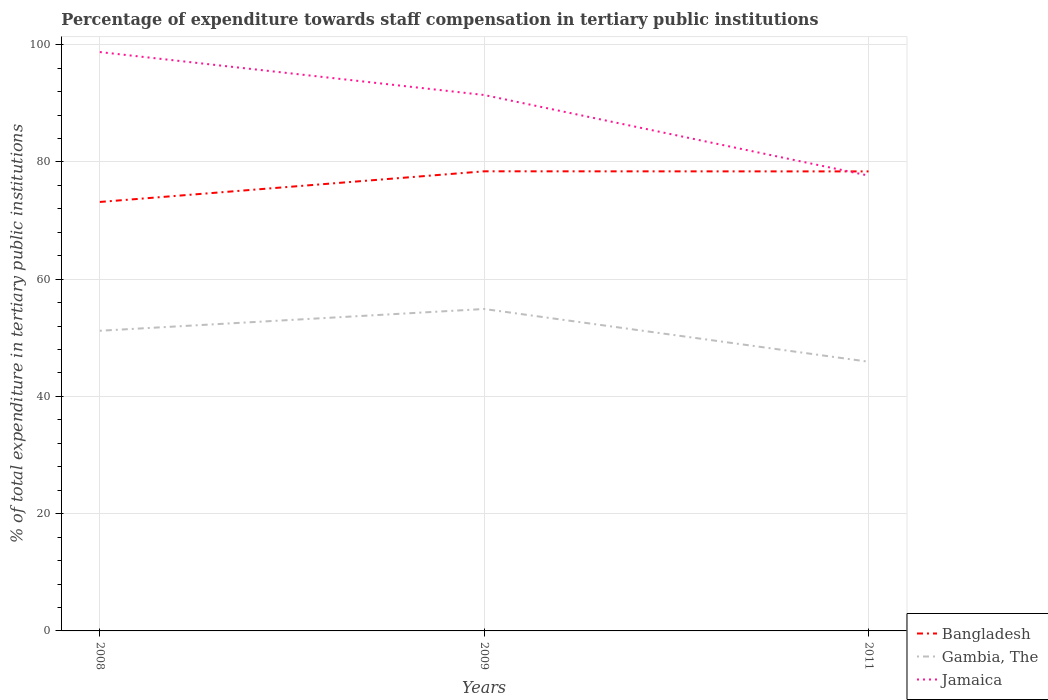Across all years, what is the maximum percentage of expenditure towards staff compensation in Jamaica?
Provide a succinct answer. 77.66. What is the total percentage of expenditure towards staff compensation in Bangladesh in the graph?
Your response must be concise. -5.23. What is the difference between the highest and the second highest percentage of expenditure towards staff compensation in Bangladesh?
Make the answer very short. 5.23. What is the difference between the highest and the lowest percentage of expenditure towards staff compensation in Jamaica?
Your answer should be compact. 2. Is the percentage of expenditure towards staff compensation in Jamaica strictly greater than the percentage of expenditure towards staff compensation in Bangladesh over the years?
Your answer should be very brief. No. How many years are there in the graph?
Make the answer very short. 3. Are the values on the major ticks of Y-axis written in scientific E-notation?
Make the answer very short. No. Does the graph contain any zero values?
Provide a succinct answer. No. What is the title of the graph?
Your response must be concise. Percentage of expenditure towards staff compensation in tertiary public institutions. Does "Turkey" appear as one of the legend labels in the graph?
Your response must be concise. No. What is the label or title of the X-axis?
Your response must be concise. Years. What is the label or title of the Y-axis?
Your answer should be compact. % of total expenditure in tertiary public institutions. What is the % of total expenditure in tertiary public institutions in Bangladesh in 2008?
Provide a short and direct response. 73.17. What is the % of total expenditure in tertiary public institutions in Gambia, The in 2008?
Keep it short and to the point. 51.2. What is the % of total expenditure in tertiary public institutions in Jamaica in 2008?
Provide a short and direct response. 98.74. What is the % of total expenditure in tertiary public institutions of Bangladesh in 2009?
Provide a succinct answer. 78.4. What is the % of total expenditure in tertiary public institutions in Gambia, The in 2009?
Provide a succinct answer. 54.91. What is the % of total expenditure in tertiary public institutions in Jamaica in 2009?
Your response must be concise. 91.41. What is the % of total expenditure in tertiary public institutions of Bangladesh in 2011?
Make the answer very short. 78.38. What is the % of total expenditure in tertiary public institutions in Gambia, The in 2011?
Your answer should be compact. 45.92. What is the % of total expenditure in tertiary public institutions in Jamaica in 2011?
Provide a succinct answer. 77.66. Across all years, what is the maximum % of total expenditure in tertiary public institutions of Bangladesh?
Your answer should be compact. 78.4. Across all years, what is the maximum % of total expenditure in tertiary public institutions of Gambia, The?
Your answer should be very brief. 54.91. Across all years, what is the maximum % of total expenditure in tertiary public institutions of Jamaica?
Your response must be concise. 98.74. Across all years, what is the minimum % of total expenditure in tertiary public institutions in Bangladesh?
Offer a terse response. 73.17. Across all years, what is the minimum % of total expenditure in tertiary public institutions in Gambia, The?
Provide a short and direct response. 45.92. Across all years, what is the minimum % of total expenditure in tertiary public institutions in Jamaica?
Your response must be concise. 77.66. What is the total % of total expenditure in tertiary public institutions of Bangladesh in the graph?
Your response must be concise. 229.95. What is the total % of total expenditure in tertiary public institutions of Gambia, The in the graph?
Keep it short and to the point. 152.03. What is the total % of total expenditure in tertiary public institutions in Jamaica in the graph?
Make the answer very short. 267.81. What is the difference between the % of total expenditure in tertiary public institutions of Bangladesh in 2008 and that in 2009?
Offer a very short reply. -5.23. What is the difference between the % of total expenditure in tertiary public institutions in Gambia, The in 2008 and that in 2009?
Offer a terse response. -3.71. What is the difference between the % of total expenditure in tertiary public institutions of Jamaica in 2008 and that in 2009?
Your answer should be very brief. 7.32. What is the difference between the % of total expenditure in tertiary public institutions in Bangladesh in 2008 and that in 2011?
Provide a short and direct response. -5.21. What is the difference between the % of total expenditure in tertiary public institutions in Gambia, The in 2008 and that in 2011?
Ensure brevity in your answer.  5.28. What is the difference between the % of total expenditure in tertiary public institutions in Jamaica in 2008 and that in 2011?
Provide a succinct answer. 21.07. What is the difference between the % of total expenditure in tertiary public institutions of Bangladesh in 2009 and that in 2011?
Offer a very short reply. 0.02. What is the difference between the % of total expenditure in tertiary public institutions of Gambia, The in 2009 and that in 2011?
Keep it short and to the point. 8.99. What is the difference between the % of total expenditure in tertiary public institutions in Jamaica in 2009 and that in 2011?
Ensure brevity in your answer.  13.75. What is the difference between the % of total expenditure in tertiary public institutions in Bangladesh in 2008 and the % of total expenditure in tertiary public institutions in Gambia, The in 2009?
Give a very brief answer. 18.26. What is the difference between the % of total expenditure in tertiary public institutions in Bangladesh in 2008 and the % of total expenditure in tertiary public institutions in Jamaica in 2009?
Ensure brevity in your answer.  -18.24. What is the difference between the % of total expenditure in tertiary public institutions in Gambia, The in 2008 and the % of total expenditure in tertiary public institutions in Jamaica in 2009?
Your answer should be very brief. -40.21. What is the difference between the % of total expenditure in tertiary public institutions in Bangladesh in 2008 and the % of total expenditure in tertiary public institutions in Gambia, The in 2011?
Provide a succinct answer. 27.25. What is the difference between the % of total expenditure in tertiary public institutions of Bangladesh in 2008 and the % of total expenditure in tertiary public institutions of Jamaica in 2011?
Keep it short and to the point. -4.49. What is the difference between the % of total expenditure in tertiary public institutions in Gambia, The in 2008 and the % of total expenditure in tertiary public institutions in Jamaica in 2011?
Make the answer very short. -26.46. What is the difference between the % of total expenditure in tertiary public institutions of Bangladesh in 2009 and the % of total expenditure in tertiary public institutions of Gambia, The in 2011?
Offer a very short reply. 32.48. What is the difference between the % of total expenditure in tertiary public institutions in Bangladesh in 2009 and the % of total expenditure in tertiary public institutions in Jamaica in 2011?
Provide a short and direct response. 0.73. What is the difference between the % of total expenditure in tertiary public institutions in Gambia, The in 2009 and the % of total expenditure in tertiary public institutions in Jamaica in 2011?
Keep it short and to the point. -22.75. What is the average % of total expenditure in tertiary public institutions in Bangladesh per year?
Make the answer very short. 76.65. What is the average % of total expenditure in tertiary public institutions in Gambia, The per year?
Make the answer very short. 50.68. What is the average % of total expenditure in tertiary public institutions in Jamaica per year?
Make the answer very short. 89.27. In the year 2008, what is the difference between the % of total expenditure in tertiary public institutions of Bangladesh and % of total expenditure in tertiary public institutions of Gambia, The?
Offer a very short reply. 21.97. In the year 2008, what is the difference between the % of total expenditure in tertiary public institutions of Bangladesh and % of total expenditure in tertiary public institutions of Jamaica?
Your answer should be compact. -25.57. In the year 2008, what is the difference between the % of total expenditure in tertiary public institutions in Gambia, The and % of total expenditure in tertiary public institutions in Jamaica?
Offer a very short reply. -47.54. In the year 2009, what is the difference between the % of total expenditure in tertiary public institutions in Bangladesh and % of total expenditure in tertiary public institutions in Gambia, The?
Offer a terse response. 23.49. In the year 2009, what is the difference between the % of total expenditure in tertiary public institutions of Bangladesh and % of total expenditure in tertiary public institutions of Jamaica?
Your answer should be compact. -13.02. In the year 2009, what is the difference between the % of total expenditure in tertiary public institutions of Gambia, The and % of total expenditure in tertiary public institutions of Jamaica?
Ensure brevity in your answer.  -36.5. In the year 2011, what is the difference between the % of total expenditure in tertiary public institutions in Bangladesh and % of total expenditure in tertiary public institutions in Gambia, The?
Make the answer very short. 32.46. In the year 2011, what is the difference between the % of total expenditure in tertiary public institutions in Bangladesh and % of total expenditure in tertiary public institutions in Jamaica?
Offer a terse response. 0.72. In the year 2011, what is the difference between the % of total expenditure in tertiary public institutions in Gambia, The and % of total expenditure in tertiary public institutions in Jamaica?
Offer a terse response. -31.75. What is the ratio of the % of total expenditure in tertiary public institutions of Bangladesh in 2008 to that in 2009?
Give a very brief answer. 0.93. What is the ratio of the % of total expenditure in tertiary public institutions in Gambia, The in 2008 to that in 2009?
Your response must be concise. 0.93. What is the ratio of the % of total expenditure in tertiary public institutions of Jamaica in 2008 to that in 2009?
Your answer should be very brief. 1.08. What is the ratio of the % of total expenditure in tertiary public institutions of Bangladesh in 2008 to that in 2011?
Ensure brevity in your answer.  0.93. What is the ratio of the % of total expenditure in tertiary public institutions in Gambia, The in 2008 to that in 2011?
Make the answer very short. 1.11. What is the ratio of the % of total expenditure in tertiary public institutions in Jamaica in 2008 to that in 2011?
Ensure brevity in your answer.  1.27. What is the ratio of the % of total expenditure in tertiary public institutions of Bangladesh in 2009 to that in 2011?
Provide a short and direct response. 1. What is the ratio of the % of total expenditure in tertiary public institutions in Gambia, The in 2009 to that in 2011?
Offer a very short reply. 1.2. What is the ratio of the % of total expenditure in tertiary public institutions of Jamaica in 2009 to that in 2011?
Ensure brevity in your answer.  1.18. What is the difference between the highest and the second highest % of total expenditure in tertiary public institutions in Bangladesh?
Keep it short and to the point. 0.02. What is the difference between the highest and the second highest % of total expenditure in tertiary public institutions of Gambia, The?
Your answer should be compact. 3.71. What is the difference between the highest and the second highest % of total expenditure in tertiary public institutions of Jamaica?
Your response must be concise. 7.32. What is the difference between the highest and the lowest % of total expenditure in tertiary public institutions in Bangladesh?
Provide a short and direct response. 5.23. What is the difference between the highest and the lowest % of total expenditure in tertiary public institutions in Gambia, The?
Offer a terse response. 8.99. What is the difference between the highest and the lowest % of total expenditure in tertiary public institutions of Jamaica?
Offer a very short reply. 21.07. 